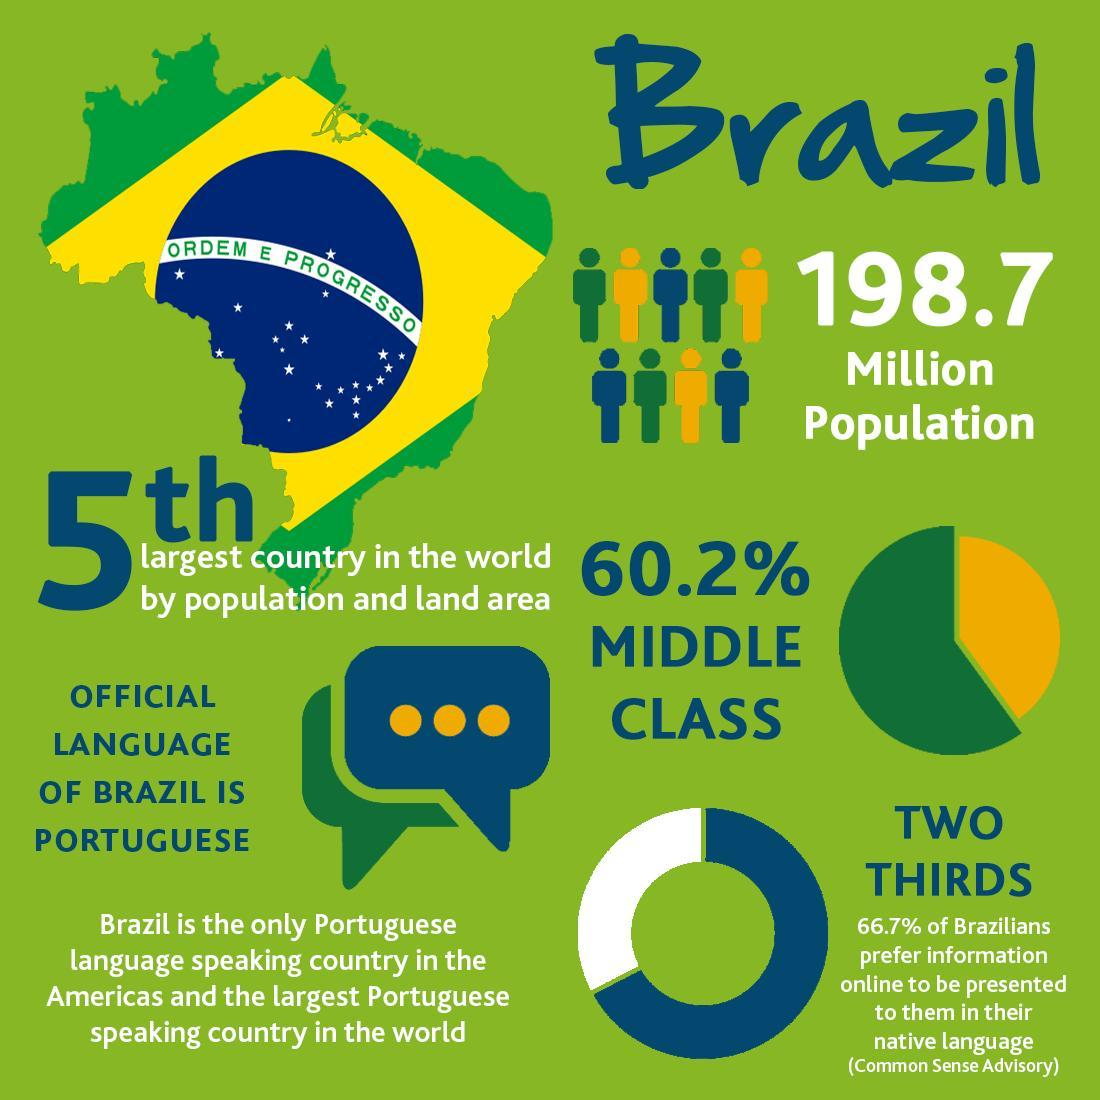What percent of population of Brazil doesn't belong to middle class?
Answer the question with a short phrase. 39.8% 